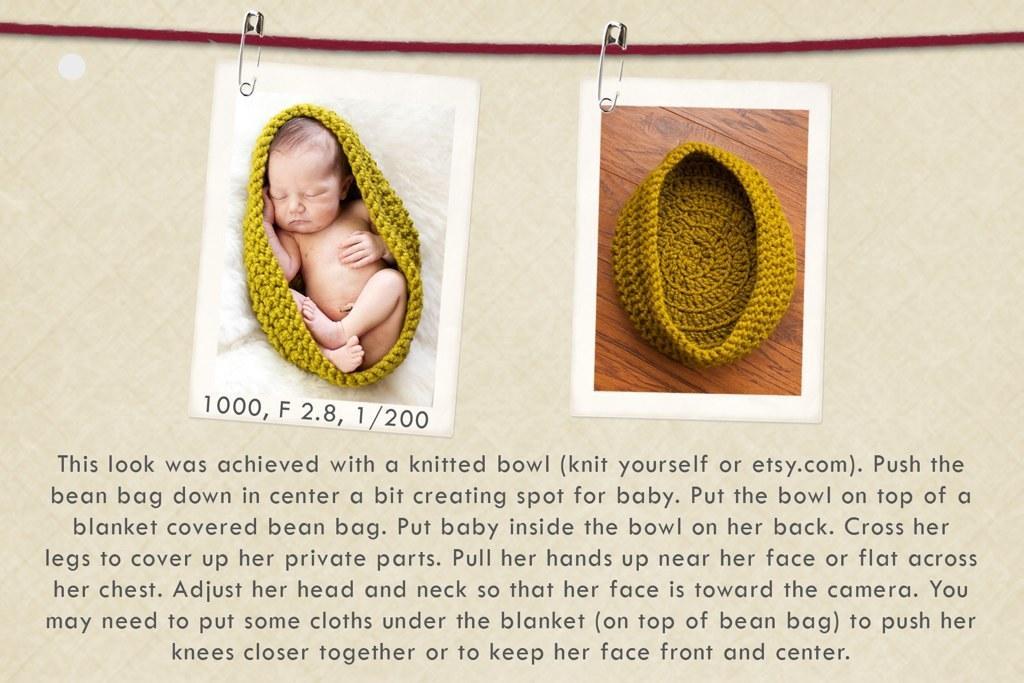Please provide a concise description of this image. These safety pins are pinned to these photos and rope. Something written on this image. In this picture we can see baby is sleeping. In the other image we can see crochet on wooden surface. 